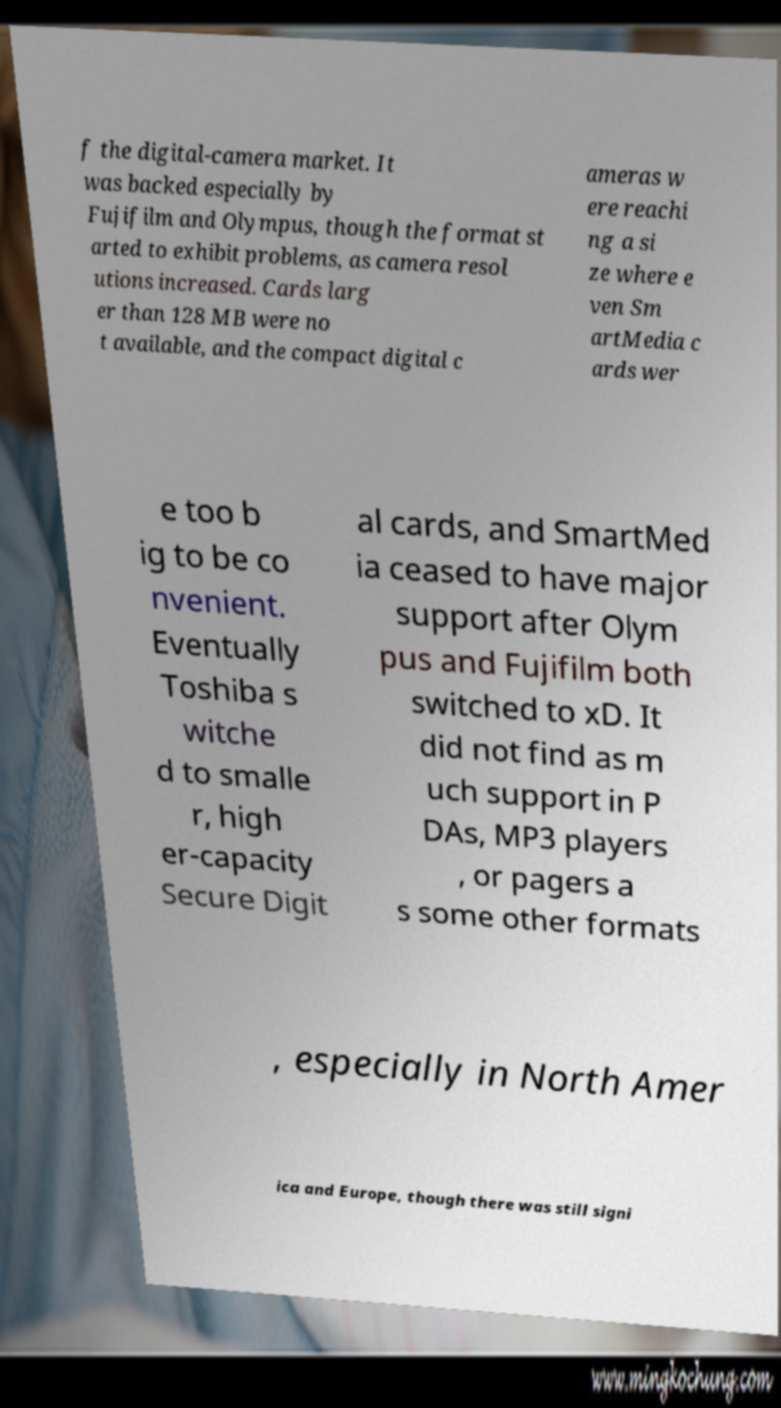Please read and relay the text visible in this image. What does it say? f the digital-camera market. It was backed especially by Fujifilm and Olympus, though the format st arted to exhibit problems, as camera resol utions increased. Cards larg er than 128 MB were no t available, and the compact digital c ameras w ere reachi ng a si ze where e ven Sm artMedia c ards wer e too b ig to be co nvenient. Eventually Toshiba s witche d to smalle r, high er-capacity Secure Digit al cards, and SmartMed ia ceased to have major support after Olym pus and Fujifilm both switched to xD. It did not find as m uch support in P DAs, MP3 players , or pagers a s some other formats , especially in North Amer ica and Europe, though there was still signi 